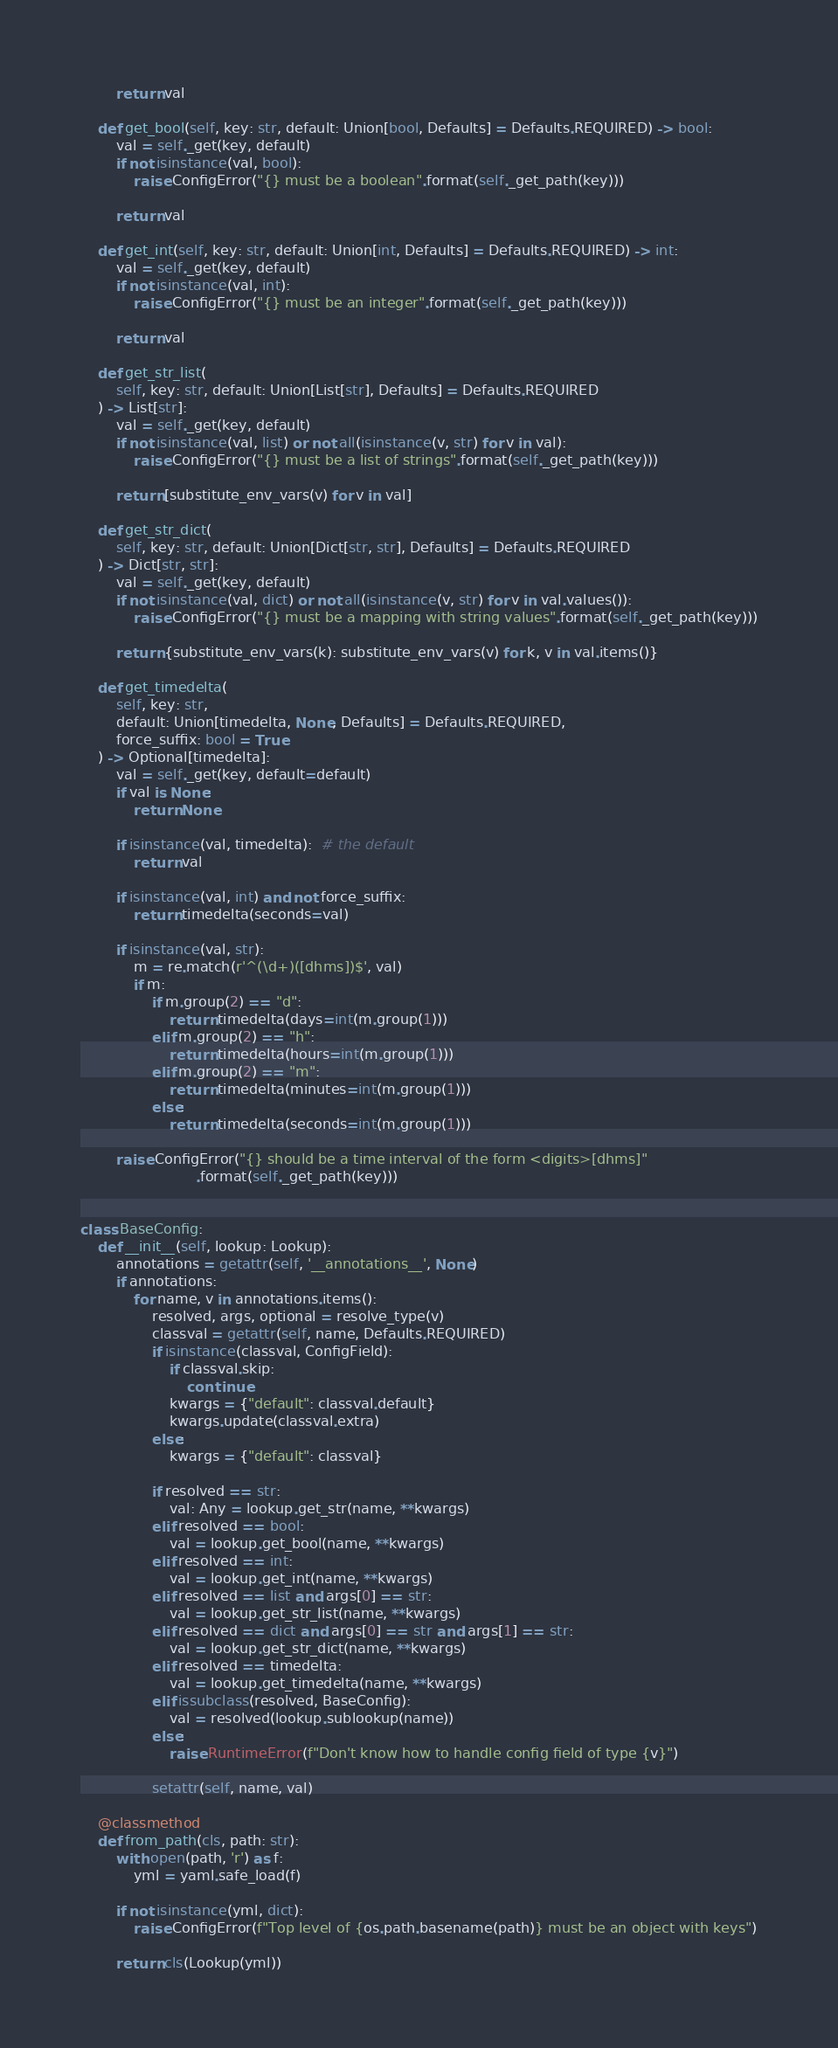<code> <loc_0><loc_0><loc_500><loc_500><_Python_>
        return val

    def get_bool(self, key: str, default: Union[bool, Defaults] = Defaults.REQUIRED) -> bool:
        val = self._get(key, default)
        if not isinstance(val, bool):
            raise ConfigError("{} must be a boolean".format(self._get_path(key)))

        return val

    def get_int(self, key: str, default: Union[int, Defaults] = Defaults.REQUIRED) -> int:
        val = self._get(key, default)
        if not isinstance(val, int):
            raise ConfigError("{} must be an integer".format(self._get_path(key)))

        return val

    def get_str_list(
        self, key: str, default: Union[List[str], Defaults] = Defaults.REQUIRED
    ) -> List[str]:
        val = self._get(key, default)
        if not isinstance(val, list) or not all(isinstance(v, str) for v in val):
            raise ConfigError("{} must be a list of strings".format(self._get_path(key)))

        return [substitute_env_vars(v) for v in val]

    def get_str_dict(
        self, key: str, default: Union[Dict[str, str], Defaults] = Defaults.REQUIRED
    ) -> Dict[str, str]:
        val = self._get(key, default)
        if not isinstance(val, dict) or not all(isinstance(v, str) for v in val.values()):
            raise ConfigError("{} must be a mapping with string values".format(self._get_path(key)))

        return {substitute_env_vars(k): substitute_env_vars(v) for k, v in val.items()}

    def get_timedelta(
        self, key: str,
        default: Union[timedelta, None, Defaults] = Defaults.REQUIRED,
        force_suffix: bool = True
    ) -> Optional[timedelta]:
        val = self._get(key, default=default)
        if val is None:
            return None

        if isinstance(val, timedelta):  # the default
            return val

        if isinstance(val, int) and not force_suffix:
            return timedelta(seconds=val)

        if isinstance(val, str):
            m = re.match(r'^(\d+)([dhms])$', val)
            if m:
                if m.group(2) == "d":
                    return timedelta(days=int(m.group(1)))
                elif m.group(2) == "h":
                    return timedelta(hours=int(m.group(1)))
                elif m.group(2) == "m":
                    return timedelta(minutes=int(m.group(1)))
                else:
                    return timedelta(seconds=int(m.group(1)))

        raise ConfigError("{} should be a time interval of the form <digits>[dhms]"
                          .format(self._get_path(key)))


class BaseConfig:
    def __init__(self, lookup: Lookup):
        annotations = getattr(self, '__annotations__', None)
        if annotations:
            for name, v in annotations.items():
                resolved, args, optional = resolve_type(v)
                classval = getattr(self, name, Defaults.REQUIRED)
                if isinstance(classval, ConfigField):
                    if classval.skip:
                        continue
                    kwargs = {"default": classval.default}
                    kwargs.update(classval.extra)
                else:
                    kwargs = {"default": classval}

                if resolved == str:
                    val: Any = lookup.get_str(name, **kwargs)
                elif resolved == bool:
                    val = lookup.get_bool(name, **kwargs)
                elif resolved == int:
                    val = lookup.get_int(name, **kwargs)
                elif resolved == list and args[0] == str:
                    val = lookup.get_str_list(name, **kwargs)
                elif resolved == dict and args[0] == str and args[1] == str:
                    val = lookup.get_str_dict(name, **kwargs)
                elif resolved == timedelta:
                    val = lookup.get_timedelta(name, **kwargs)
                elif issubclass(resolved, BaseConfig):
                    val = resolved(lookup.sublookup(name))
                else:
                    raise RuntimeError(f"Don't know how to handle config field of type {v}")

                setattr(self, name, val)

    @classmethod
    def from_path(cls, path: str):
        with open(path, 'r') as f:
            yml = yaml.safe_load(f)

        if not isinstance(yml, dict):
            raise ConfigError(f"Top level of {os.path.basename(path)} must be an object with keys")

        return cls(Lookup(yml))
</code> 